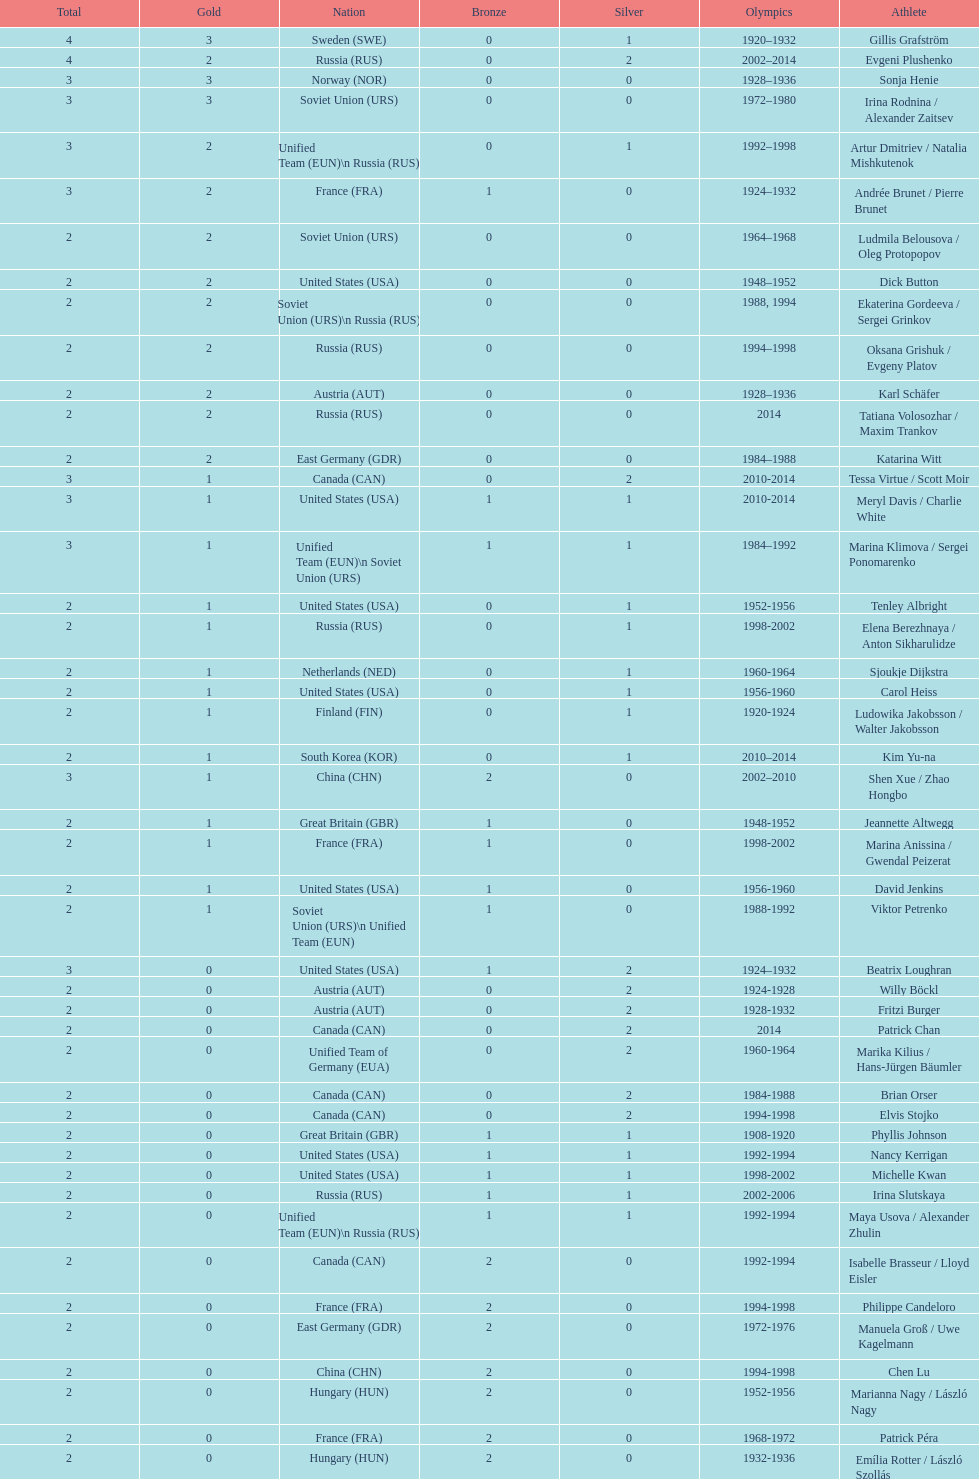Can you give me this table as a dict? {'header': ['Total', 'Gold', 'Nation', 'Bronze', 'Silver', 'Olympics', 'Athlete'], 'rows': [['4', '3', 'Sweden\xa0(SWE)', '0', '1', '1920–1932', 'Gillis Grafström'], ['4', '2', 'Russia\xa0(RUS)', '0', '2', '2002–2014', 'Evgeni Plushenko'], ['3', '3', 'Norway\xa0(NOR)', '0', '0', '1928–1936', 'Sonja Henie'], ['3', '3', 'Soviet Union\xa0(URS)', '0', '0', '1972–1980', 'Irina Rodnina / Alexander Zaitsev'], ['3', '2', 'Unified Team\xa0(EUN)\\n\xa0Russia\xa0(RUS)', '0', '1', '1992–1998', 'Artur Dmitriev / Natalia Mishkutenok'], ['3', '2', 'France\xa0(FRA)', '1', '0', '1924–1932', 'Andrée Brunet / Pierre Brunet'], ['2', '2', 'Soviet Union\xa0(URS)', '0', '0', '1964–1968', 'Ludmila Belousova / Oleg Protopopov'], ['2', '2', 'United States\xa0(USA)', '0', '0', '1948–1952', 'Dick Button'], ['2', '2', 'Soviet Union\xa0(URS)\\n\xa0Russia\xa0(RUS)', '0', '0', '1988, 1994', 'Ekaterina Gordeeva / Sergei Grinkov'], ['2', '2', 'Russia\xa0(RUS)', '0', '0', '1994–1998', 'Oksana Grishuk / Evgeny Platov'], ['2', '2', 'Austria\xa0(AUT)', '0', '0', '1928–1936', 'Karl Schäfer'], ['2', '2', 'Russia\xa0(RUS)', '0', '0', '2014', 'Tatiana Volosozhar / Maxim Trankov'], ['2', '2', 'East Germany\xa0(GDR)', '0', '0', '1984–1988', 'Katarina Witt'], ['3', '1', 'Canada\xa0(CAN)', '0', '2', '2010-2014', 'Tessa Virtue / Scott Moir'], ['3', '1', 'United States\xa0(USA)', '1', '1', '2010-2014', 'Meryl Davis / Charlie White'], ['3', '1', 'Unified Team\xa0(EUN)\\n\xa0Soviet Union\xa0(URS)', '1', '1', '1984–1992', 'Marina Klimova / Sergei Ponomarenko'], ['2', '1', 'United States\xa0(USA)', '0', '1', '1952-1956', 'Tenley Albright'], ['2', '1', 'Russia\xa0(RUS)', '0', '1', '1998-2002', 'Elena Berezhnaya / Anton Sikharulidze'], ['2', '1', 'Netherlands\xa0(NED)', '0', '1', '1960-1964', 'Sjoukje Dijkstra'], ['2', '1', 'United States\xa0(USA)', '0', '1', '1956-1960', 'Carol Heiss'], ['2', '1', 'Finland\xa0(FIN)', '0', '1', '1920-1924', 'Ludowika Jakobsson / Walter Jakobsson'], ['2', '1', 'South Korea\xa0(KOR)', '0', '1', '2010–2014', 'Kim Yu-na'], ['3', '1', 'China\xa0(CHN)', '2', '0', '2002–2010', 'Shen Xue / Zhao Hongbo'], ['2', '1', 'Great Britain\xa0(GBR)', '1', '0', '1948-1952', 'Jeannette Altwegg'], ['2', '1', 'France\xa0(FRA)', '1', '0', '1998-2002', 'Marina Anissina / Gwendal Peizerat'], ['2', '1', 'United States\xa0(USA)', '1', '0', '1956-1960', 'David Jenkins'], ['2', '1', 'Soviet Union\xa0(URS)\\n\xa0Unified Team\xa0(EUN)', '1', '0', '1988-1992', 'Viktor Petrenko'], ['3', '0', 'United States\xa0(USA)', '1', '2', '1924–1932', 'Beatrix Loughran'], ['2', '0', 'Austria\xa0(AUT)', '0', '2', '1924-1928', 'Willy Böckl'], ['2', '0', 'Austria\xa0(AUT)', '0', '2', '1928-1932', 'Fritzi Burger'], ['2', '0', 'Canada\xa0(CAN)', '0', '2', '2014', 'Patrick Chan'], ['2', '0', 'Unified Team of Germany\xa0(EUA)', '0', '2', '1960-1964', 'Marika Kilius / Hans-Jürgen Bäumler'], ['2', '0', 'Canada\xa0(CAN)', '0', '2', '1984-1988', 'Brian Orser'], ['2', '0', 'Canada\xa0(CAN)', '0', '2', '1994-1998', 'Elvis Stojko'], ['2', '0', 'Great Britain\xa0(GBR)', '1', '1', '1908-1920', 'Phyllis Johnson'], ['2', '0', 'United States\xa0(USA)', '1', '1', '1992-1994', 'Nancy Kerrigan'], ['2', '0', 'United States\xa0(USA)', '1', '1', '1998-2002', 'Michelle Kwan'], ['2', '0', 'Russia\xa0(RUS)', '1', '1', '2002-2006', 'Irina Slutskaya'], ['2', '0', 'Unified Team\xa0(EUN)\\n\xa0Russia\xa0(RUS)', '1', '1', '1992-1994', 'Maya Usova / Alexander Zhulin'], ['2', '0', 'Canada\xa0(CAN)', '2', '0', '1992-1994', 'Isabelle Brasseur / Lloyd Eisler'], ['2', '0', 'France\xa0(FRA)', '2', '0', '1994-1998', 'Philippe Candeloro'], ['2', '0', 'East Germany\xa0(GDR)', '2', '0', '1972-1976', 'Manuela Groß / Uwe Kagelmann'], ['2', '0', 'China\xa0(CHN)', '2', '0', '1994-1998', 'Chen Lu'], ['2', '0', 'Hungary\xa0(HUN)', '2', '0', '1952-1956', 'Marianna Nagy / László Nagy'], ['2', '0', 'France\xa0(FRA)', '2', '0', '1968-1972', 'Patrick Péra'], ['2', '0', 'Hungary\xa0(HUN)', '2', '0', '1932-1936', 'Emília Rotter / László Szollás'], ['2', '0', 'Germany\xa0(GER)', '2', '0', '2010-2014', 'Aliona Savchenko / Robin Szolkowy']]} How many silver medals did evgeni plushenko get? 2. 